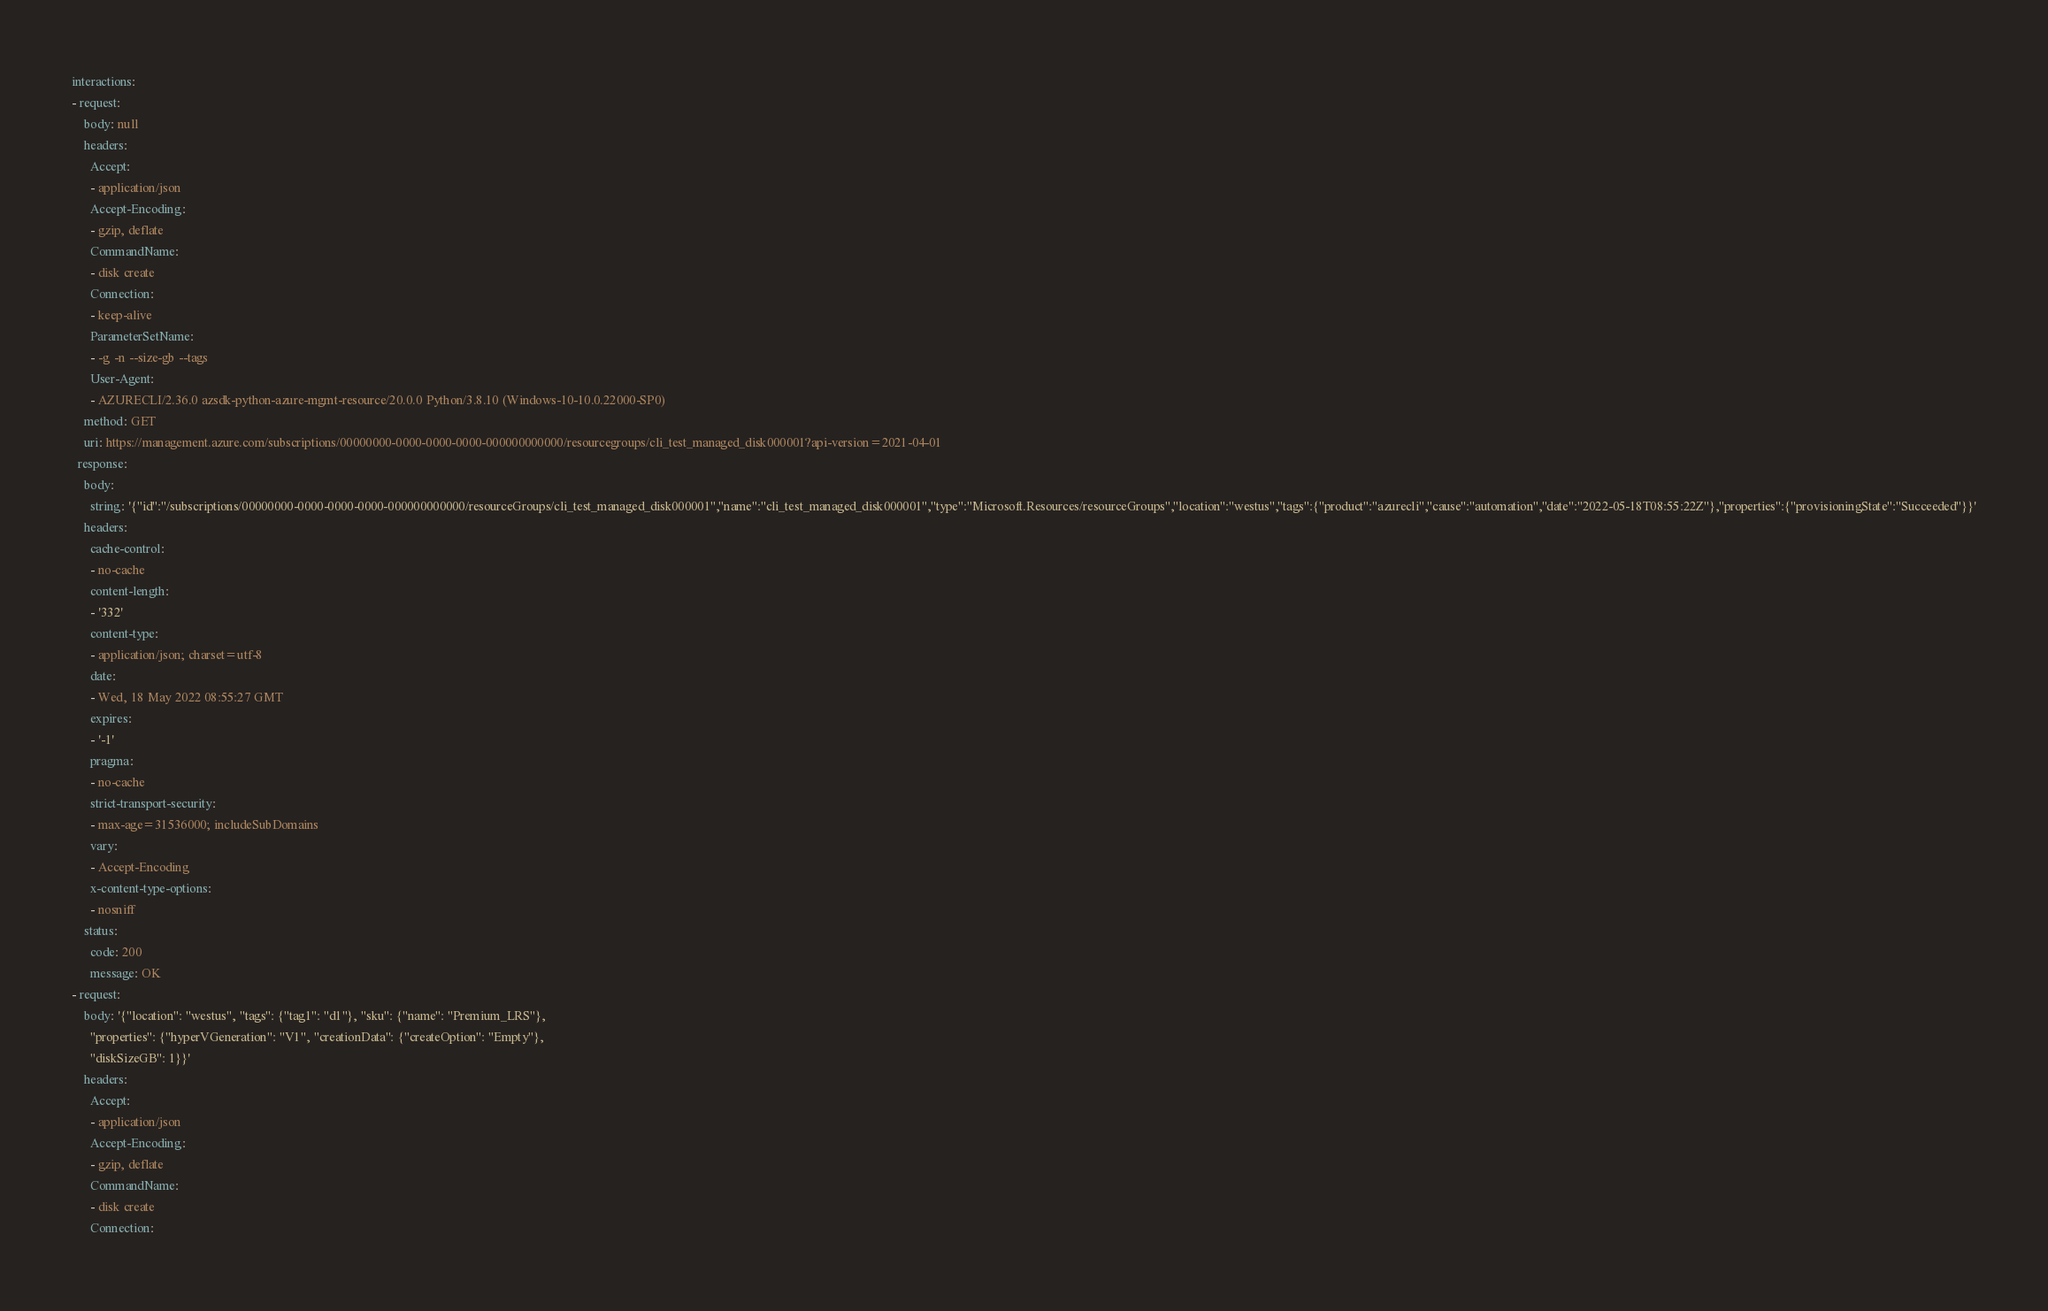<code> <loc_0><loc_0><loc_500><loc_500><_YAML_>interactions:
- request:
    body: null
    headers:
      Accept:
      - application/json
      Accept-Encoding:
      - gzip, deflate
      CommandName:
      - disk create
      Connection:
      - keep-alive
      ParameterSetName:
      - -g -n --size-gb --tags
      User-Agent:
      - AZURECLI/2.36.0 azsdk-python-azure-mgmt-resource/20.0.0 Python/3.8.10 (Windows-10-10.0.22000-SP0)
    method: GET
    uri: https://management.azure.com/subscriptions/00000000-0000-0000-0000-000000000000/resourcegroups/cli_test_managed_disk000001?api-version=2021-04-01
  response:
    body:
      string: '{"id":"/subscriptions/00000000-0000-0000-0000-000000000000/resourceGroups/cli_test_managed_disk000001","name":"cli_test_managed_disk000001","type":"Microsoft.Resources/resourceGroups","location":"westus","tags":{"product":"azurecli","cause":"automation","date":"2022-05-18T08:55:22Z"},"properties":{"provisioningState":"Succeeded"}}'
    headers:
      cache-control:
      - no-cache
      content-length:
      - '332'
      content-type:
      - application/json; charset=utf-8
      date:
      - Wed, 18 May 2022 08:55:27 GMT
      expires:
      - '-1'
      pragma:
      - no-cache
      strict-transport-security:
      - max-age=31536000; includeSubDomains
      vary:
      - Accept-Encoding
      x-content-type-options:
      - nosniff
    status:
      code: 200
      message: OK
- request:
    body: '{"location": "westus", "tags": {"tag1": "d1"}, "sku": {"name": "Premium_LRS"},
      "properties": {"hyperVGeneration": "V1", "creationData": {"createOption": "Empty"},
      "diskSizeGB": 1}}'
    headers:
      Accept:
      - application/json
      Accept-Encoding:
      - gzip, deflate
      CommandName:
      - disk create
      Connection:</code> 